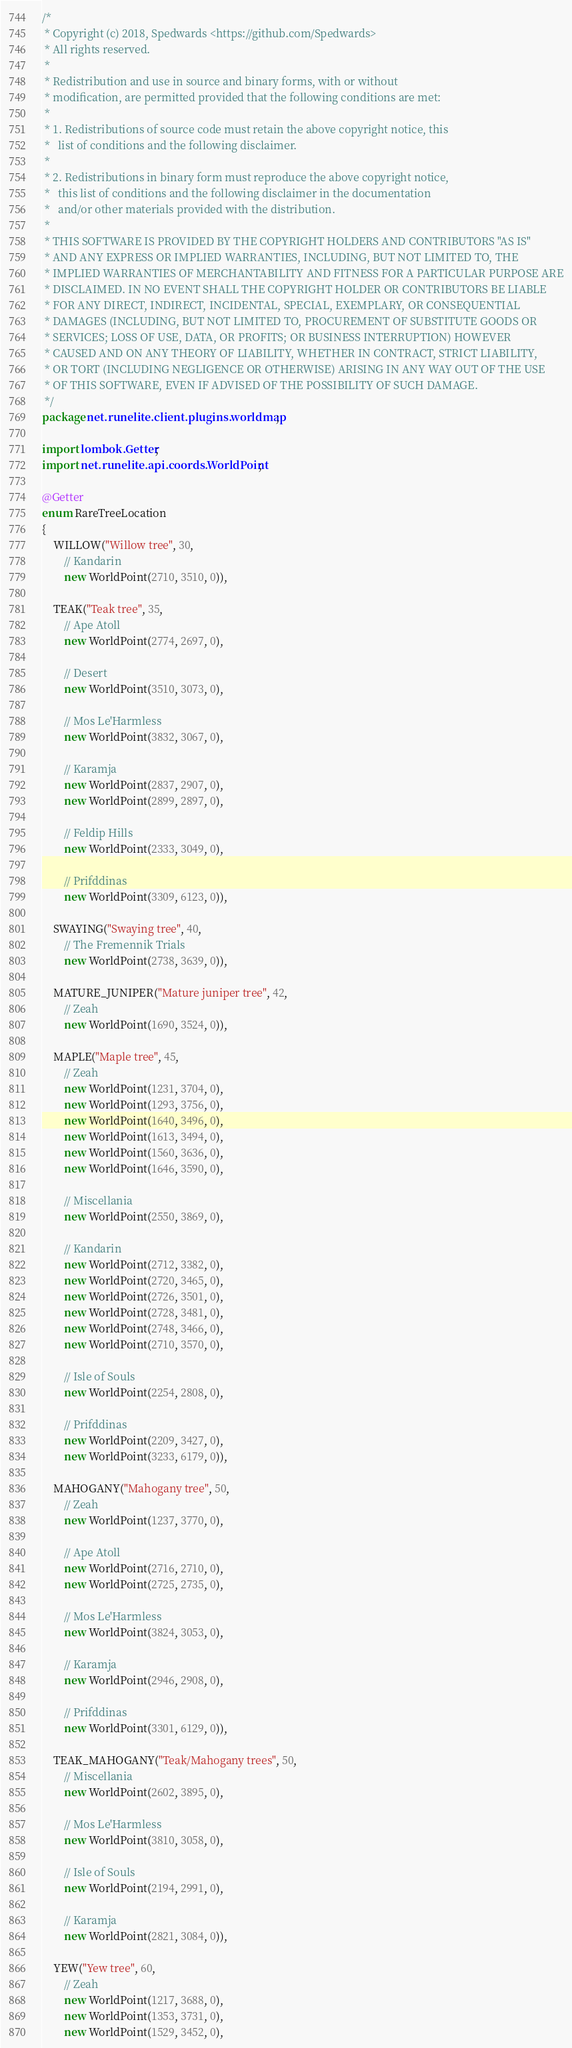Convert code to text. <code><loc_0><loc_0><loc_500><loc_500><_Java_>/*
 * Copyright (c) 2018, Spedwards <https://github.com/Spedwards>
 * All rights reserved.
 *
 * Redistribution and use in source and binary forms, with or without
 * modification, are permitted provided that the following conditions are met:
 *
 * 1. Redistributions of source code must retain the above copyright notice, this
 *   list of conditions and the following disclaimer.
 *
 * 2. Redistributions in binary form must reproduce the above copyright notice,
 *   this list of conditions and the following disclaimer in the documentation
 *   and/or other materials provided with the distribution.
 *
 * THIS SOFTWARE IS PROVIDED BY THE COPYRIGHT HOLDERS AND CONTRIBUTORS "AS IS"
 * AND ANY EXPRESS OR IMPLIED WARRANTIES, INCLUDING, BUT NOT LIMITED TO, THE
 * IMPLIED WARRANTIES OF MERCHANTABILITY AND FITNESS FOR A PARTICULAR PURPOSE ARE
 * DISCLAIMED. IN NO EVENT SHALL THE COPYRIGHT HOLDER OR CONTRIBUTORS BE LIABLE
 * FOR ANY DIRECT, INDIRECT, INCIDENTAL, SPECIAL, EXEMPLARY, OR CONSEQUENTIAL
 * DAMAGES (INCLUDING, BUT NOT LIMITED TO, PROCUREMENT OF SUBSTITUTE GOODS OR
 * SERVICES; LOSS OF USE, DATA, OR PROFITS; OR BUSINESS INTERRUPTION) HOWEVER
 * CAUSED AND ON ANY THEORY OF LIABILITY, WHETHER IN CONTRACT, STRICT LIABILITY,
 * OR TORT (INCLUDING NEGLIGENCE OR OTHERWISE) ARISING IN ANY WAY OUT OF THE USE
 * OF THIS SOFTWARE, EVEN IF ADVISED OF THE POSSIBILITY OF SUCH DAMAGE.
 */
package net.runelite.client.plugins.worldmap;

import lombok.Getter;
import net.runelite.api.coords.WorldPoint;

@Getter
enum RareTreeLocation
{
	WILLOW("Willow tree", 30,
		// Kandarin
		new WorldPoint(2710, 3510, 0)),

	TEAK("Teak tree", 35,
		// Ape Atoll
		new WorldPoint(2774, 2697, 0),

		// Desert
		new WorldPoint(3510, 3073, 0),

		// Mos Le'Harmless
		new WorldPoint(3832, 3067, 0),

		// Karamja
		new WorldPoint(2837, 2907, 0),
		new WorldPoint(2899, 2897, 0),

		// Feldip Hills
		new WorldPoint(2333, 3049, 0),

		// Prifddinas
		new WorldPoint(3309, 6123, 0)),

	SWAYING("Swaying tree", 40,
		// The Fremennik Trials
		new WorldPoint(2738, 3639, 0)),

	MATURE_JUNIPER("Mature juniper tree", 42,
		// Zeah
		new WorldPoint(1690, 3524, 0)),

	MAPLE("Maple tree", 45,
		// Zeah
		new WorldPoint(1231, 3704, 0),
		new WorldPoint(1293, 3756, 0),
		new WorldPoint(1640, 3496, 0),
		new WorldPoint(1613, 3494, 0),
		new WorldPoint(1560, 3636, 0),
		new WorldPoint(1646, 3590, 0),

		// Miscellania
		new WorldPoint(2550, 3869, 0),

		// Kandarin
		new WorldPoint(2712, 3382, 0),
		new WorldPoint(2720, 3465, 0),
		new WorldPoint(2726, 3501, 0),
		new WorldPoint(2728, 3481, 0),
		new WorldPoint(2748, 3466, 0),
		new WorldPoint(2710, 3570, 0),

		// Isle of Souls
		new WorldPoint(2254, 2808, 0),

		// Prifddinas
		new WorldPoint(2209, 3427, 0),
		new WorldPoint(3233, 6179, 0)),

	MAHOGANY("Mahogany tree", 50,
		// Zeah
		new WorldPoint(1237, 3770, 0),

		// Ape Atoll
		new WorldPoint(2716, 2710, 0),
		new WorldPoint(2725, 2735, 0),

		// Mos Le'Harmless
		new WorldPoint(3824, 3053, 0),

		// Karamja
		new WorldPoint(2946, 2908, 0),

		// Prifddinas
		new WorldPoint(3301, 6129, 0)),

	TEAK_MAHOGANY("Teak/Mahogany trees", 50,
		// Miscellania
		new WorldPoint(2602, 3895, 0),

		// Mos Le'Harmless
		new WorldPoint(3810, 3058, 0),

		// Isle of Souls
		new WorldPoint(2194, 2991, 0),

		// Karamja
		new WorldPoint(2821, 3084, 0)),

	YEW("Yew tree", 60,
		// Zeah
		new WorldPoint(1217, 3688, 0),
		new WorldPoint(1353, 3731, 0),
		new WorldPoint(1529, 3452, 0),</code> 